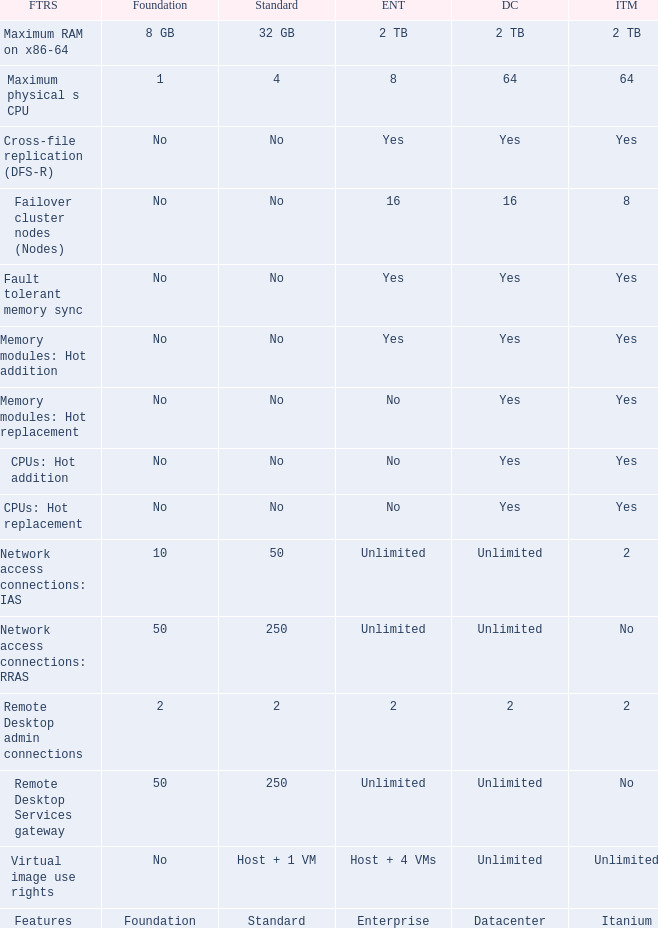What is the Datacenter for the Memory modules: hot addition Feature that has Yes listed for Itanium? Yes. 